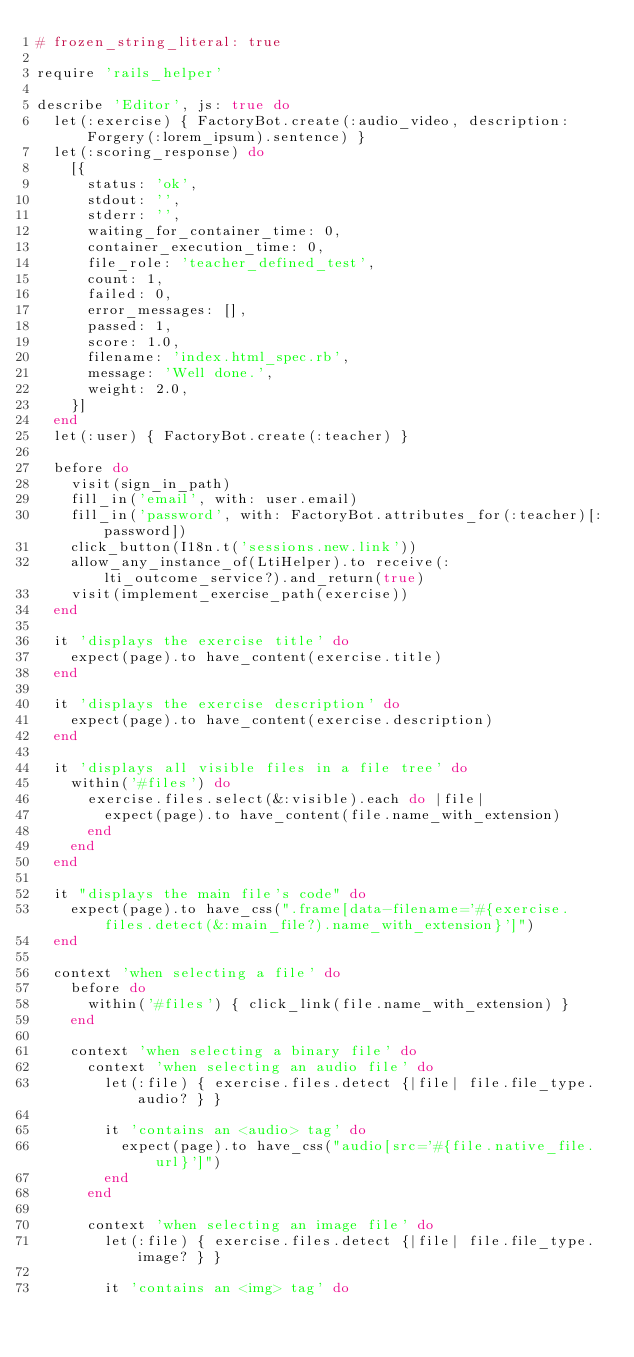Convert code to text. <code><loc_0><loc_0><loc_500><loc_500><_Ruby_># frozen_string_literal: true

require 'rails_helper'

describe 'Editor', js: true do
  let(:exercise) { FactoryBot.create(:audio_video, description: Forgery(:lorem_ipsum).sentence) }
  let(:scoring_response) do
    [{
      status: 'ok',
      stdout: '',
      stderr: '',
      waiting_for_container_time: 0,
      container_execution_time: 0,
      file_role: 'teacher_defined_test',
      count: 1,
      failed: 0,
      error_messages: [],
      passed: 1,
      score: 1.0,
      filename: 'index.html_spec.rb',
      message: 'Well done.',
      weight: 2.0,
    }]
  end
  let(:user) { FactoryBot.create(:teacher) }

  before do
    visit(sign_in_path)
    fill_in('email', with: user.email)
    fill_in('password', with: FactoryBot.attributes_for(:teacher)[:password])
    click_button(I18n.t('sessions.new.link'))
    allow_any_instance_of(LtiHelper).to receive(:lti_outcome_service?).and_return(true)
    visit(implement_exercise_path(exercise))
  end

  it 'displays the exercise title' do
    expect(page).to have_content(exercise.title)
  end

  it 'displays the exercise description' do
    expect(page).to have_content(exercise.description)
  end

  it 'displays all visible files in a file tree' do
    within('#files') do
      exercise.files.select(&:visible).each do |file|
        expect(page).to have_content(file.name_with_extension)
      end
    end
  end

  it "displays the main file's code" do
    expect(page).to have_css(".frame[data-filename='#{exercise.files.detect(&:main_file?).name_with_extension}']")
  end

  context 'when selecting a file' do
    before do
      within('#files') { click_link(file.name_with_extension) }
    end

    context 'when selecting a binary file' do
      context 'when selecting an audio file' do
        let(:file) { exercise.files.detect {|file| file.file_type.audio? } }

        it 'contains an <audio> tag' do
          expect(page).to have_css("audio[src='#{file.native_file.url}']")
        end
      end

      context 'when selecting an image file' do
        let(:file) { exercise.files.detect {|file| file.file_type.image? } }

        it 'contains an <img> tag' do</code> 